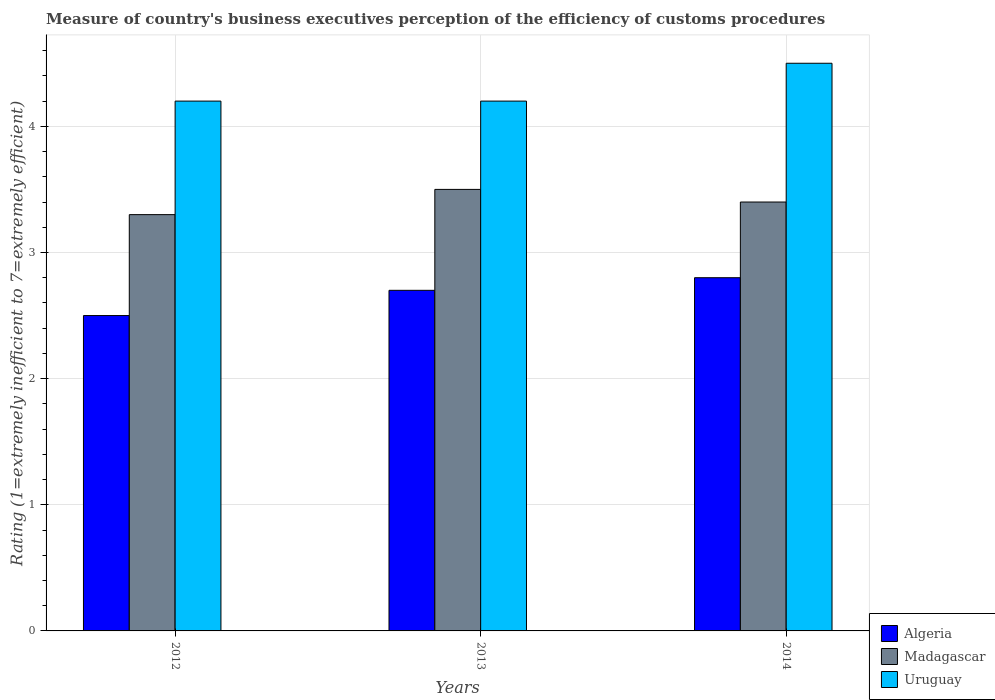Are the number of bars on each tick of the X-axis equal?
Your answer should be very brief. Yes. In which year was the rating of the efficiency of customs procedure in Madagascar maximum?
Give a very brief answer. 2013. In which year was the rating of the efficiency of customs procedure in Madagascar minimum?
Ensure brevity in your answer.  2012. What is the total rating of the efficiency of customs procedure in Uruguay in the graph?
Provide a succinct answer. 12.9. What is the difference between the rating of the efficiency of customs procedure in Madagascar in 2012 and that in 2013?
Provide a short and direct response. -0.2. What is the difference between the rating of the efficiency of customs procedure in Madagascar in 2014 and the rating of the efficiency of customs procedure in Algeria in 2013?
Your answer should be compact. 0.7. What is the average rating of the efficiency of customs procedure in Uruguay per year?
Keep it short and to the point. 4.3. In the year 2013, what is the difference between the rating of the efficiency of customs procedure in Madagascar and rating of the efficiency of customs procedure in Uruguay?
Offer a terse response. -0.7. What is the ratio of the rating of the efficiency of customs procedure in Madagascar in 2012 to that in 2013?
Provide a succinct answer. 0.94. What is the difference between the highest and the second highest rating of the efficiency of customs procedure in Uruguay?
Offer a very short reply. 0.3. What is the difference between the highest and the lowest rating of the efficiency of customs procedure in Uruguay?
Make the answer very short. 0.3. Is the sum of the rating of the efficiency of customs procedure in Algeria in 2013 and 2014 greater than the maximum rating of the efficiency of customs procedure in Uruguay across all years?
Your answer should be very brief. Yes. What does the 1st bar from the left in 2012 represents?
Give a very brief answer. Algeria. What does the 1st bar from the right in 2014 represents?
Provide a succinct answer. Uruguay. Is it the case that in every year, the sum of the rating of the efficiency of customs procedure in Uruguay and rating of the efficiency of customs procedure in Algeria is greater than the rating of the efficiency of customs procedure in Madagascar?
Your response must be concise. Yes. Does the graph contain any zero values?
Ensure brevity in your answer.  No. Where does the legend appear in the graph?
Offer a terse response. Bottom right. How are the legend labels stacked?
Provide a succinct answer. Vertical. What is the title of the graph?
Make the answer very short. Measure of country's business executives perception of the efficiency of customs procedures. What is the label or title of the Y-axis?
Keep it short and to the point. Rating (1=extremely inefficient to 7=extremely efficient). What is the Rating (1=extremely inefficient to 7=extremely efficient) of Algeria in 2012?
Ensure brevity in your answer.  2.5. What is the Rating (1=extremely inefficient to 7=extremely efficient) in Madagascar in 2012?
Provide a short and direct response. 3.3. What is the Rating (1=extremely inefficient to 7=extremely efficient) of Uruguay in 2012?
Keep it short and to the point. 4.2. What is the Rating (1=extremely inefficient to 7=extremely efficient) in Algeria in 2013?
Offer a very short reply. 2.7. What is the Rating (1=extremely inefficient to 7=extremely efficient) in Uruguay in 2013?
Provide a succinct answer. 4.2. What is the Rating (1=extremely inefficient to 7=extremely efficient) in Uruguay in 2014?
Provide a succinct answer. 4.5. Across all years, what is the maximum Rating (1=extremely inefficient to 7=extremely efficient) in Madagascar?
Your answer should be very brief. 3.5. Across all years, what is the minimum Rating (1=extremely inefficient to 7=extremely efficient) of Uruguay?
Ensure brevity in your answer.  4.2. What is the difference between the Rating (1=extremely inefficient to 7=extremely efficient) in Madagascar in 2012 and that in 2013?
Provide a succinct answer. -0.2. What is the difference between the Rating (1=extremely inefficient to 7=extremely efficient) in Algeria in 2012 and that in 2014?
Keep it short and to the point. -0.3. What is the difference between the Rating (1=extremely inefficient to 7=extremely efficient) in Algeria in 2013 and that in 2014?
Provide a short and direct response. -0.1. What is the difference between the Rating (1=extremely inefficient to 7=extremely efficient) of Uruguay in 2013 and that in 2014?
Make the answer very short. -0.3. What is the difference between the Rating (1=extremely inefficient to 7=extremely efficient) of Algeria in 2012 and the Rating (1=extremely inefficient to 7=extremely efficient) of Uruguay in 2013?
Offer a very short reply. -1.7. What is the difference between the Rating (1=extremely inefficient to 7=extremely efficient) in Algeria in 2012 and the Rating (1=extremely inefficient to 7=extremely efficient) in Uruguay in 2014?
Ensure brevity in your answer.  -2. What is the difference between the Rating (1=extremely inefficient to 7=extremely efficient) in Madagascar in 2013 and the Rating (1=extremely inefficient to 7=extremely efficient) in Uruguay in 2014?
Give a very brief answer. -1. What is the average Rating (1=extremely inefficient to 7=extremely efficient) of Algeria per year?
Provide a succinct answer. 2.67. In the year 2012, what is the difference between the Rating (1=extremely inefficient to 7=extremely efficient) in Algeria and Rating (1=extremely inefficient to 7=extremely efficient) in Uruguay?
Your response must be concise. -1.7. In the year 2012, what is the difference between the Rating (1=extremely inefficient to 7=extremely efficient) in Madagascar and Rating (1=extremely inefficient to 7=extremely efficient) in Uruguay?
Make the answer very short. -0.9. What is the ratio of the Rating (1=extremely inefficient to 7=extremely efficient) of Algeria in 2012 to that in 2013?
Your response must be concise. 0.93. What is the ratio of the Rating (1=extremely inefficient to 7=extremely efficient) of Madagascar in 2012 to that in 2013?
Offer a very short reply. 0.94. What is the ratio of the Rating (1=extremely inefficient to 7=extremely efficient) of Algeria in 2012 to that in 2014?
Your response must be concise. 0.89. What is the ratio of the Rating (1=extremely inefficient to 7=extremely efficient) of Madagascar in 2012 to that in 2014?
Your answer should be compact. 0.97. What is the ratio of the Rating (1=extremely inefficient to 7=extremely efficient) in Algeria in 2013 to that in 2014?
Provide a short and direct response. 0.96. What is the ratio of the Rating (1=extremely inefficient to 7=extremely efficient) in Madagascar in 2013 to that in 2014?
Give a very brief answer. 1.03. What is the ratio of the Rating (1=extremely inefficient to 7=extremely efficient) of Uruguay in 2013 to that in 2014?
Keep it short and to the point. 0.93. What is the difference between the highest and the second highest Rating (1=extremely inefficient to 7=extremely efficient) of Uruguay?
Your answer should be very brief. 0.3. What is the difference between the highest and the lowest Rating (1=extremely inefficient to 7=extremely efficient) in Madagascar?
Ensure brevity in your answer.  0.2. 